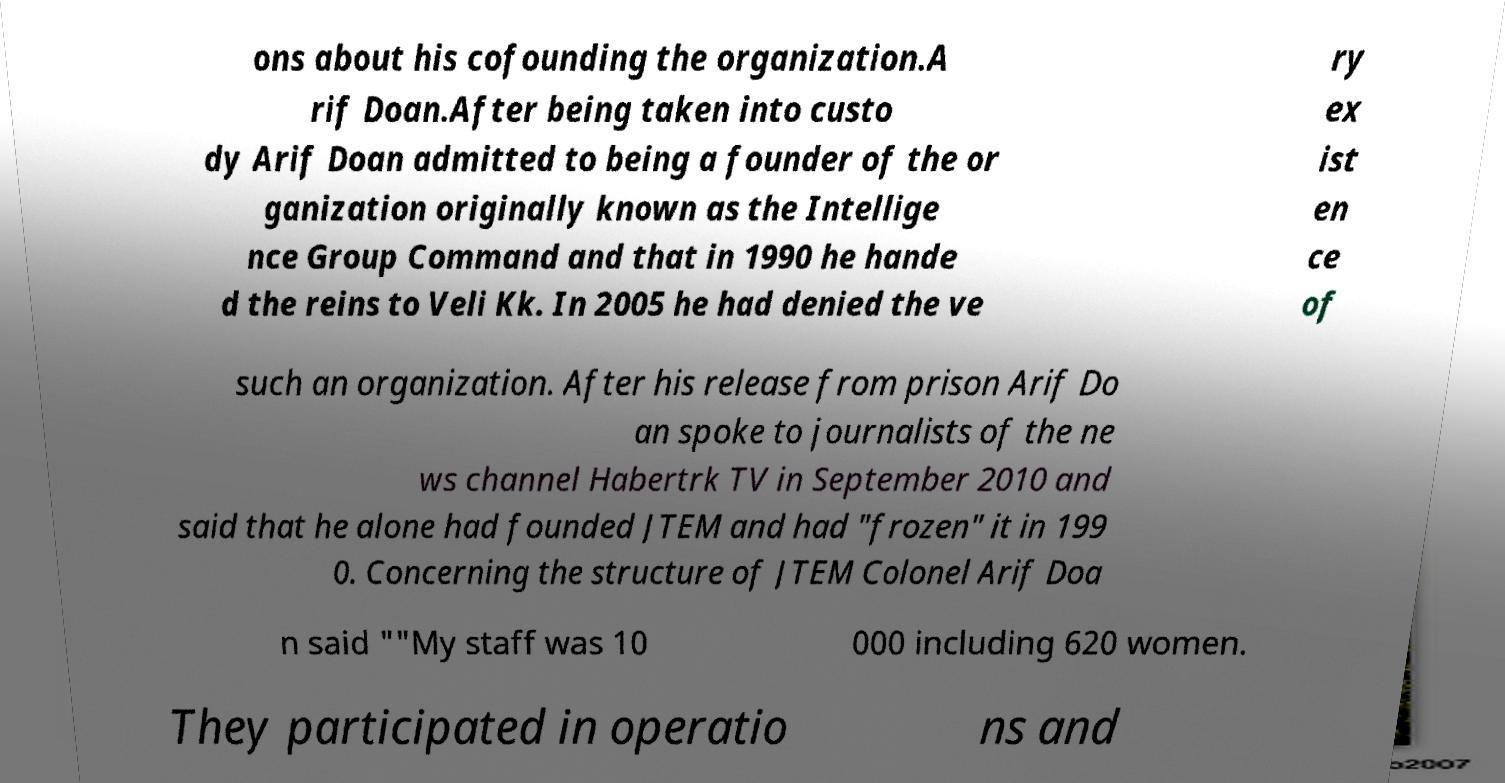Could you extract and type out the text from this image? ons about his cofounding the organization.A rif Doan.After being taken into custo dy Arif Doan admitted to being a founder of the or ganization originally known as the Intellige nce Group Command and that in 1990 he hande d the reins to Veli Kk. In 2005 he had denied the ve ry ex ist en ce of such an organization. After his release from prison Arif Do an spoke to journalists of the ne ws channel Habertrk TV in September 2010 and said that he alone had founded JTEM and had "frozen" it in 199 0. Concerning the structure of JTEM Colonel Arif Doa n said ""My staff was 10 000 including 620 women. They participated in operatio ns and 